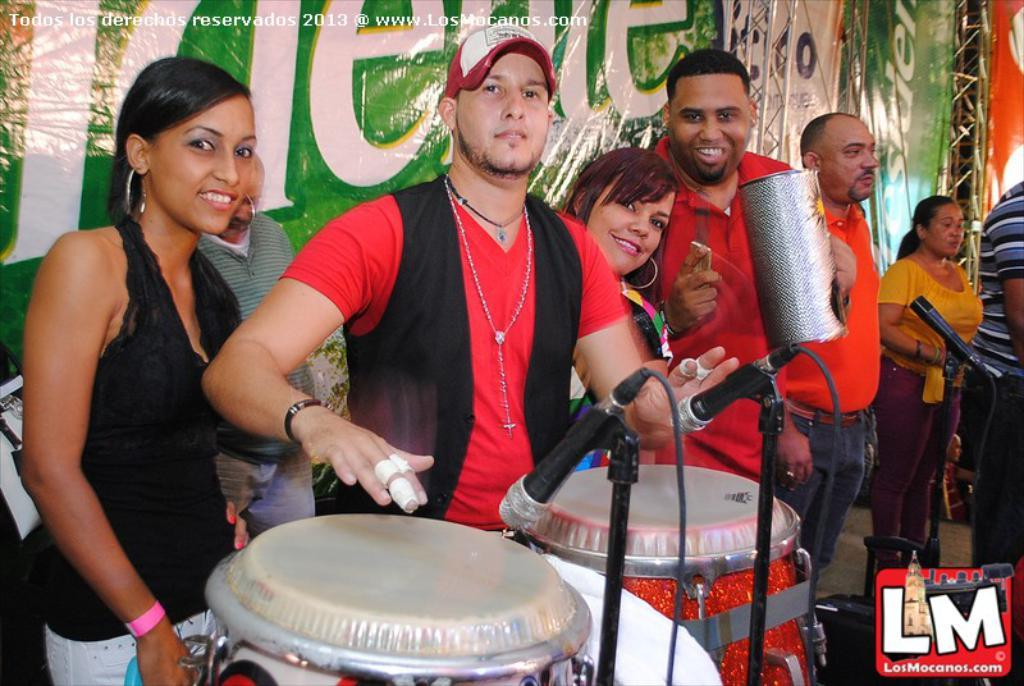How many people are in the image? There are people in the image, but the exact number is not specified. What is the man doing in the image? The man is playing drums in the image. What equipment is present for amplifying sound? There are microphones with stands in the image. What can be seen in the background of the image? There is a banner in the background of the image. Where is the logo located in the image? The logo is in the bottom right side of the image. What type of corn can be seen growing in the image? There is no corn present in the image. What sound can be heard during the thunderstorm in the image? There is no thunderstorm or any sound mentioned in the image. 